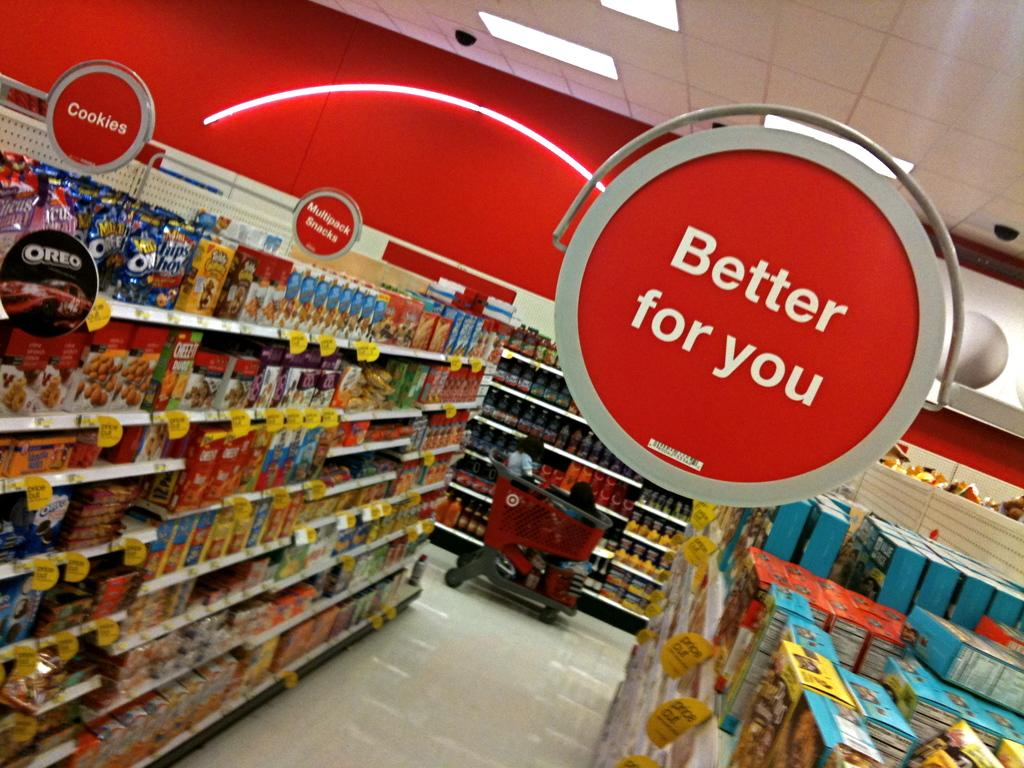<image>
Share a concise interpretation of the image provided. Aisle of Target with signs hanging one tells you better for you 